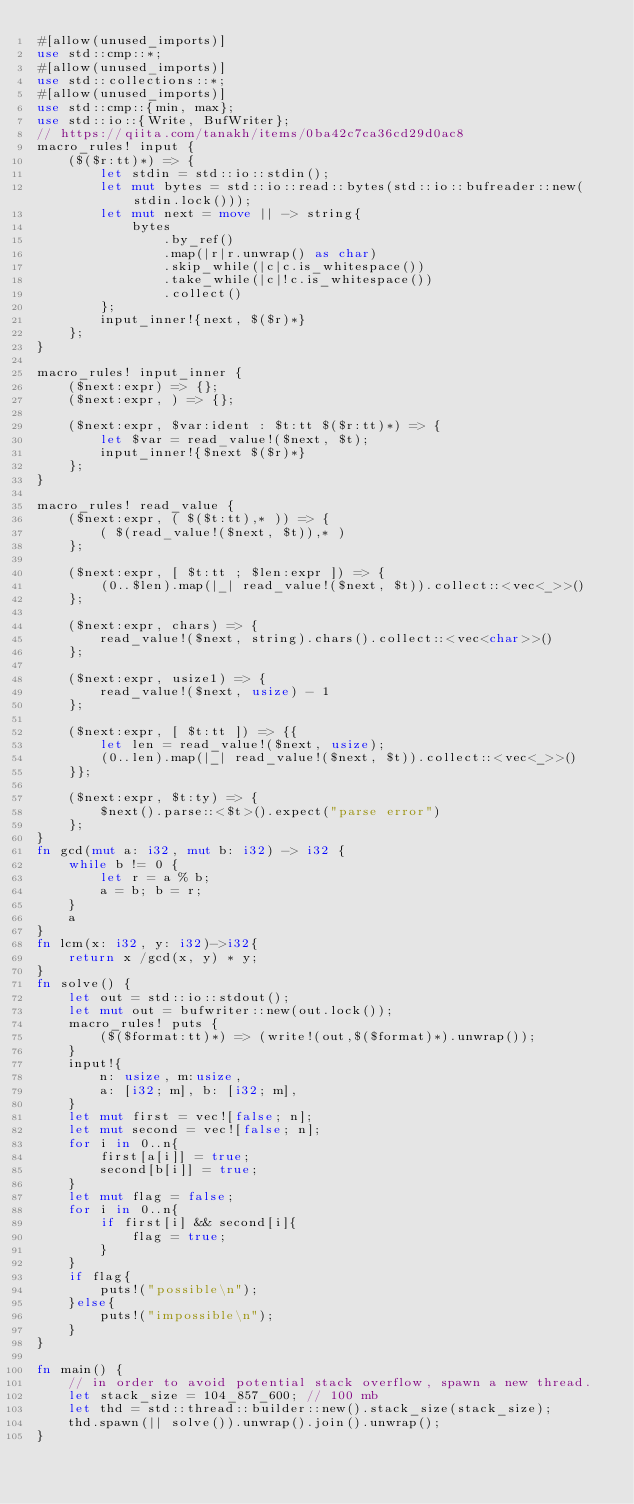Convert code to text. <code><loc_0><loc_0><loc_500><loc_500><_Rust_>#[allow(unused_imports)]
use std::cmp::*;
#[allow(unused_imports)]
use std::collections::*;
#[allow(unused_imports)]
use std::cmp::{min, max};
use std::io::{Write, BufWriter};
// https://qiita.com/tanakh/items/0ba42c7ca36cd29d0ac8
macro_rules! input {
    ($($r:tt)*) => {
        let stdin = std::io::stdin();
        let mut bytes = std::io::read::bytes(std::io::bufreader::new(stdin.lock()));
        let mut next = move || -> string{
            bytes
                .by_ref()
                .map(|r|r.unwrap() as char)
                .skip_while(|c|c.is_whitespace())
                .take_while(|c|!c.is_whitespace())
                .collect()
        };
        input_inner!{next, $($r)*}
    };
}

macro_rules! input_inner {
    ($next:expr) => {};
    ($next:expr, ) => {};

    ($next:expr, $var:ident : $t:tt $($r:tt)*) => {
        let $var = read_value!($next, $t);
        input_inner!{$next $($r)*}
    };
}

macro_rules! read_value {
    ($next:expr, ( $($t:tt),* )) => {
        ( $(read_value!($next, $t)),* )
    };

    ($next:expr, [ $t:tt ; $len:expr ]) => {
        (0..$len).map(|_| read_value!($next, $t)).collect::<vec<_>>()
    };

    ($next:expr, chars) => {
        read_value!($next, string).chars().collect::<vec<char>>()
    };

    ($next:expr, usize1) => {
        read_value!($next, usize) - 1
    };

    ($next:expr, [ $t:tt ]) => {{
        let len = read_value!($next, usize);
        (0..len).map(|_| read_value!($next, $t)).collect::<vec<_>>()
    }};

    ($next:expr, $t:ty) => {
        $next().parse::<$t>().expect("parse error")
    };
}
fn gcd(mut a: i32, mut b: i32) -> i32 {
    while b != 0 {
        let r = a % b;
        a = b; b = r;
    }
    a
}
fn lcm(x: i32, y: i32)->i32{
    return x /gcd(x, y) * y;
}
fn solve() {
    let out = std::io::stdout();
    let mut out = bufwriter::new(out.lock());
    macro_rules! puts {
        ($($format:tt)*) => (write!(out,$($format)*).unwrap());
    }
    input!{
        n: usize, m:usize,
        a: [i32; m], b: [i32; m],
    }
    let mut first = vec![false; n];
    let mut second = vec![false; n];
    for i in 0..n{
        first[a[i]] = true;
        second[b[i]] = true;
    }
    let mut flag = false;
    for i in 0..n{
        if first[i] && second[i]{
            flag = true;
        }
    }
    if flag{
        puts!("possible\n");
    }else{
        puts!("impossible\n");
    }
}

fn main() {
    // in order to avoid potential stack overflow, spawn a new thread.
    let stack_size = 104_857_600; // 100 mb
    let thd = std::thread::builder::new().stack_size(stack_size);
    thd.spawn(|| solve()).unwrap().join().unwrap();
}
</code> 